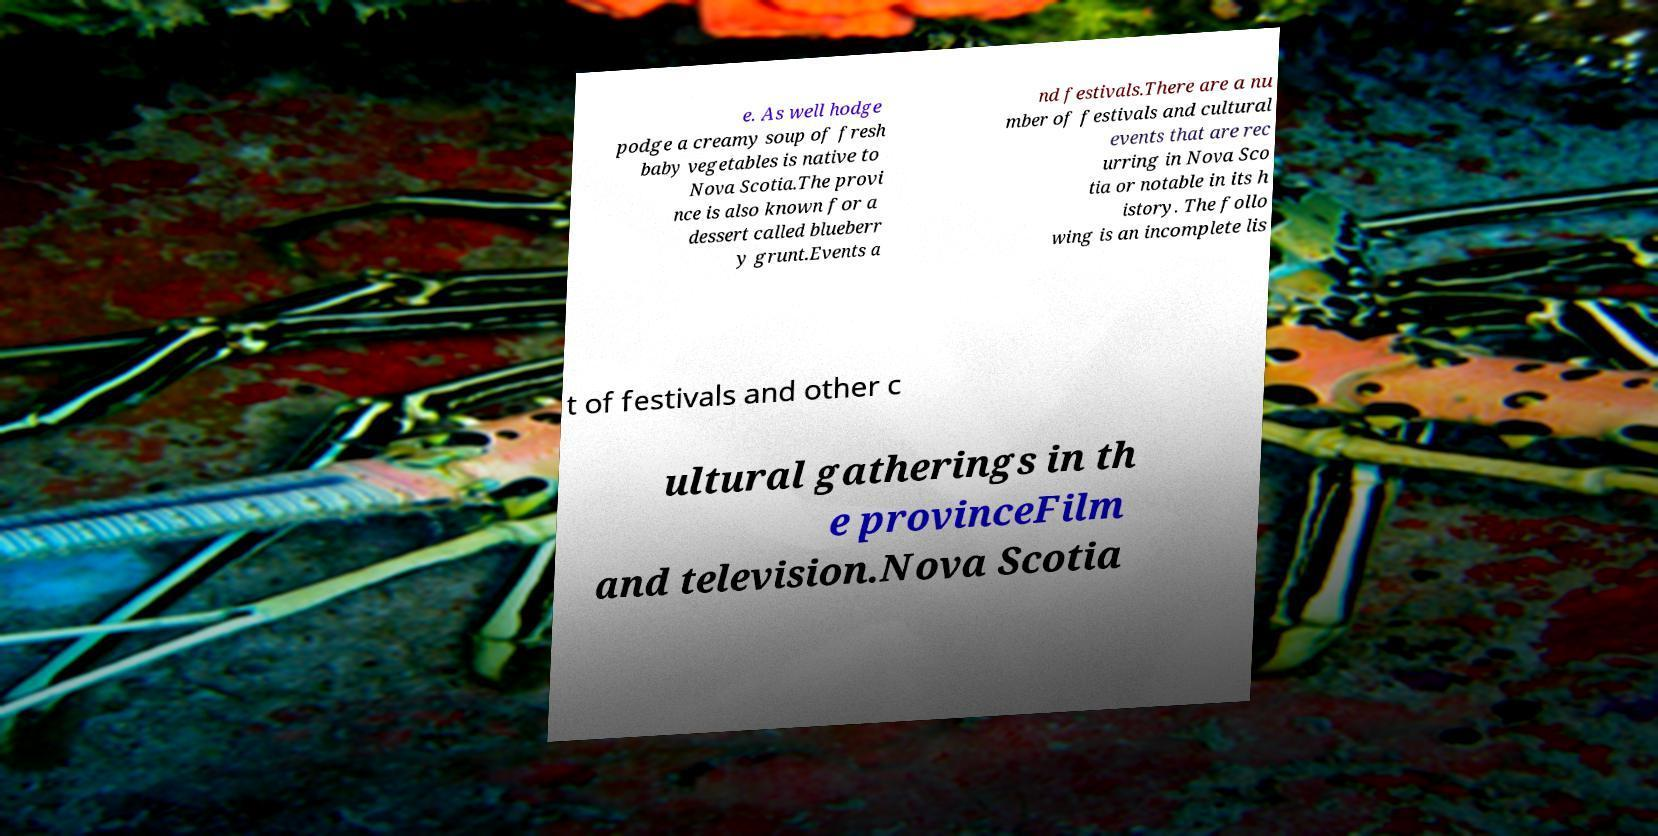For documentation purposes, I need the text within this image transcribed. Could you provide that? e. As well hodge podge a creamy soup of fresh baby vegetables is native to Nova Scotia.The provi nce is also known for a dessert called blueberr y grunt.Events a nd festivals.There are a nu mber of festivals and cultural events that are rec urring in Nova Sco tia or notable in its h istory. The follo wing is an incomplete lis t of festivals and other c ultural gatherings in th e provinceFilm and television.Nova Scotia 